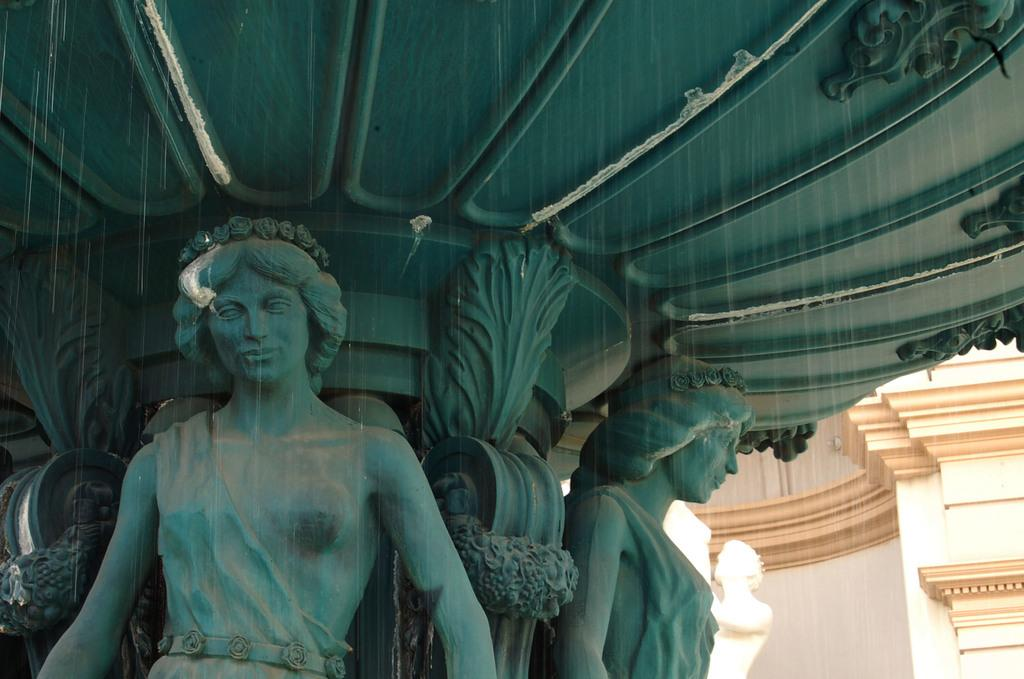What type of art is present in the image? There are sculptures in the image. Can you describe the structure visible at the bottom right side of the image? There appears to be a building at the bottom right side of the image. What type of amusement can be seen in the image? There is no amusement present in the image; it features sculptures and a building. How many roses are visible in the image? There are no roses present in the image. 